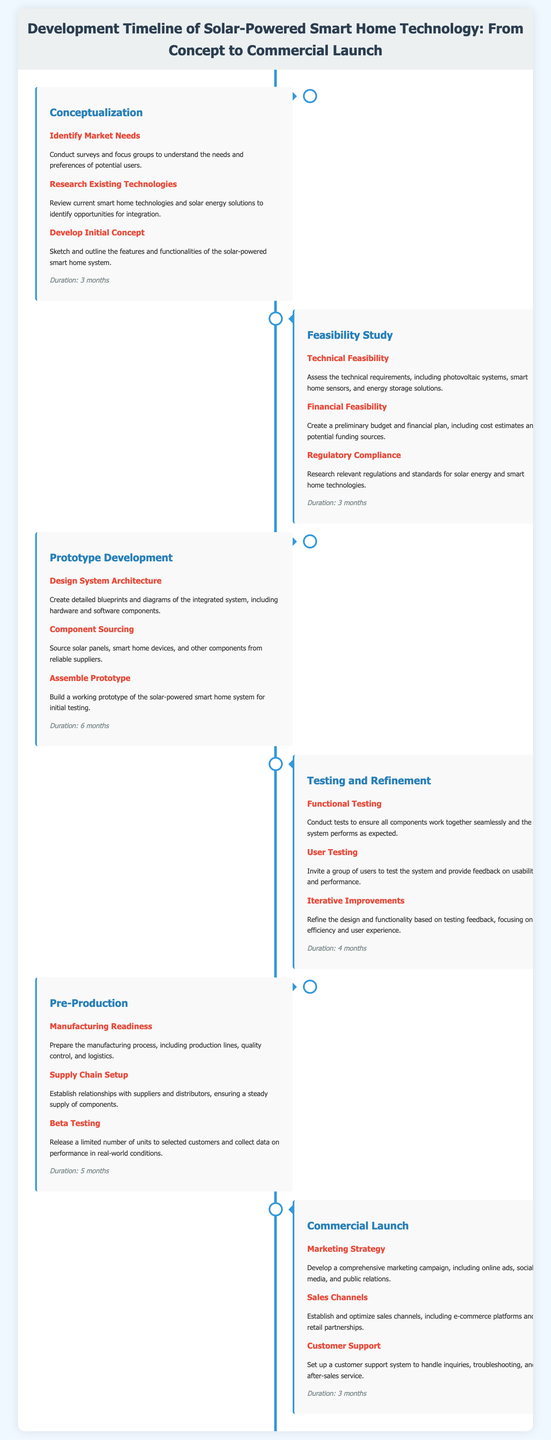What is the duration of the Conceptualization stage? The duration is specified in the document under the Conceptualization section.
Answer: 3 months How many months does Prototype Development take? The document states the duration of Prototype Development in the respective section.
Answer: 6 months What is the first task listed in the Testing and Refinement stage? The first task is provided in the Testing and Refinement section, highlighting its order and focus.
Answer: Functional Testing Which stage focuses on manufacturing readiness? The stage focusing on manufacturing readiness is directly identified in the document.
Answer: Pre-Production What is the last stage before commercial launch? The last stage before the commercial launch is clearly labeled in the document.
Answer: Pre-Production What is the primary focus of the Marketing Strategy task? The Marketing Strategy task is elaborated upon in the Commercial Launch section of the document.
Answer: Comprehensive marketing campaign How long is the Testing and Refinement duration? The duration for the Testing and Refinement stage is mentioned explicitly within that section.
Answer: 4 months What type of feedback is gathered during User Testing? The document specifies the type of feedback expected during User Testing in the Testing and Refinement stage.
Answer: Usability and performance What is a key component of the Pre-Production stage? A key component is listed in the Pre-Production section of the timeline.
Answer: Manufacturing readiness 